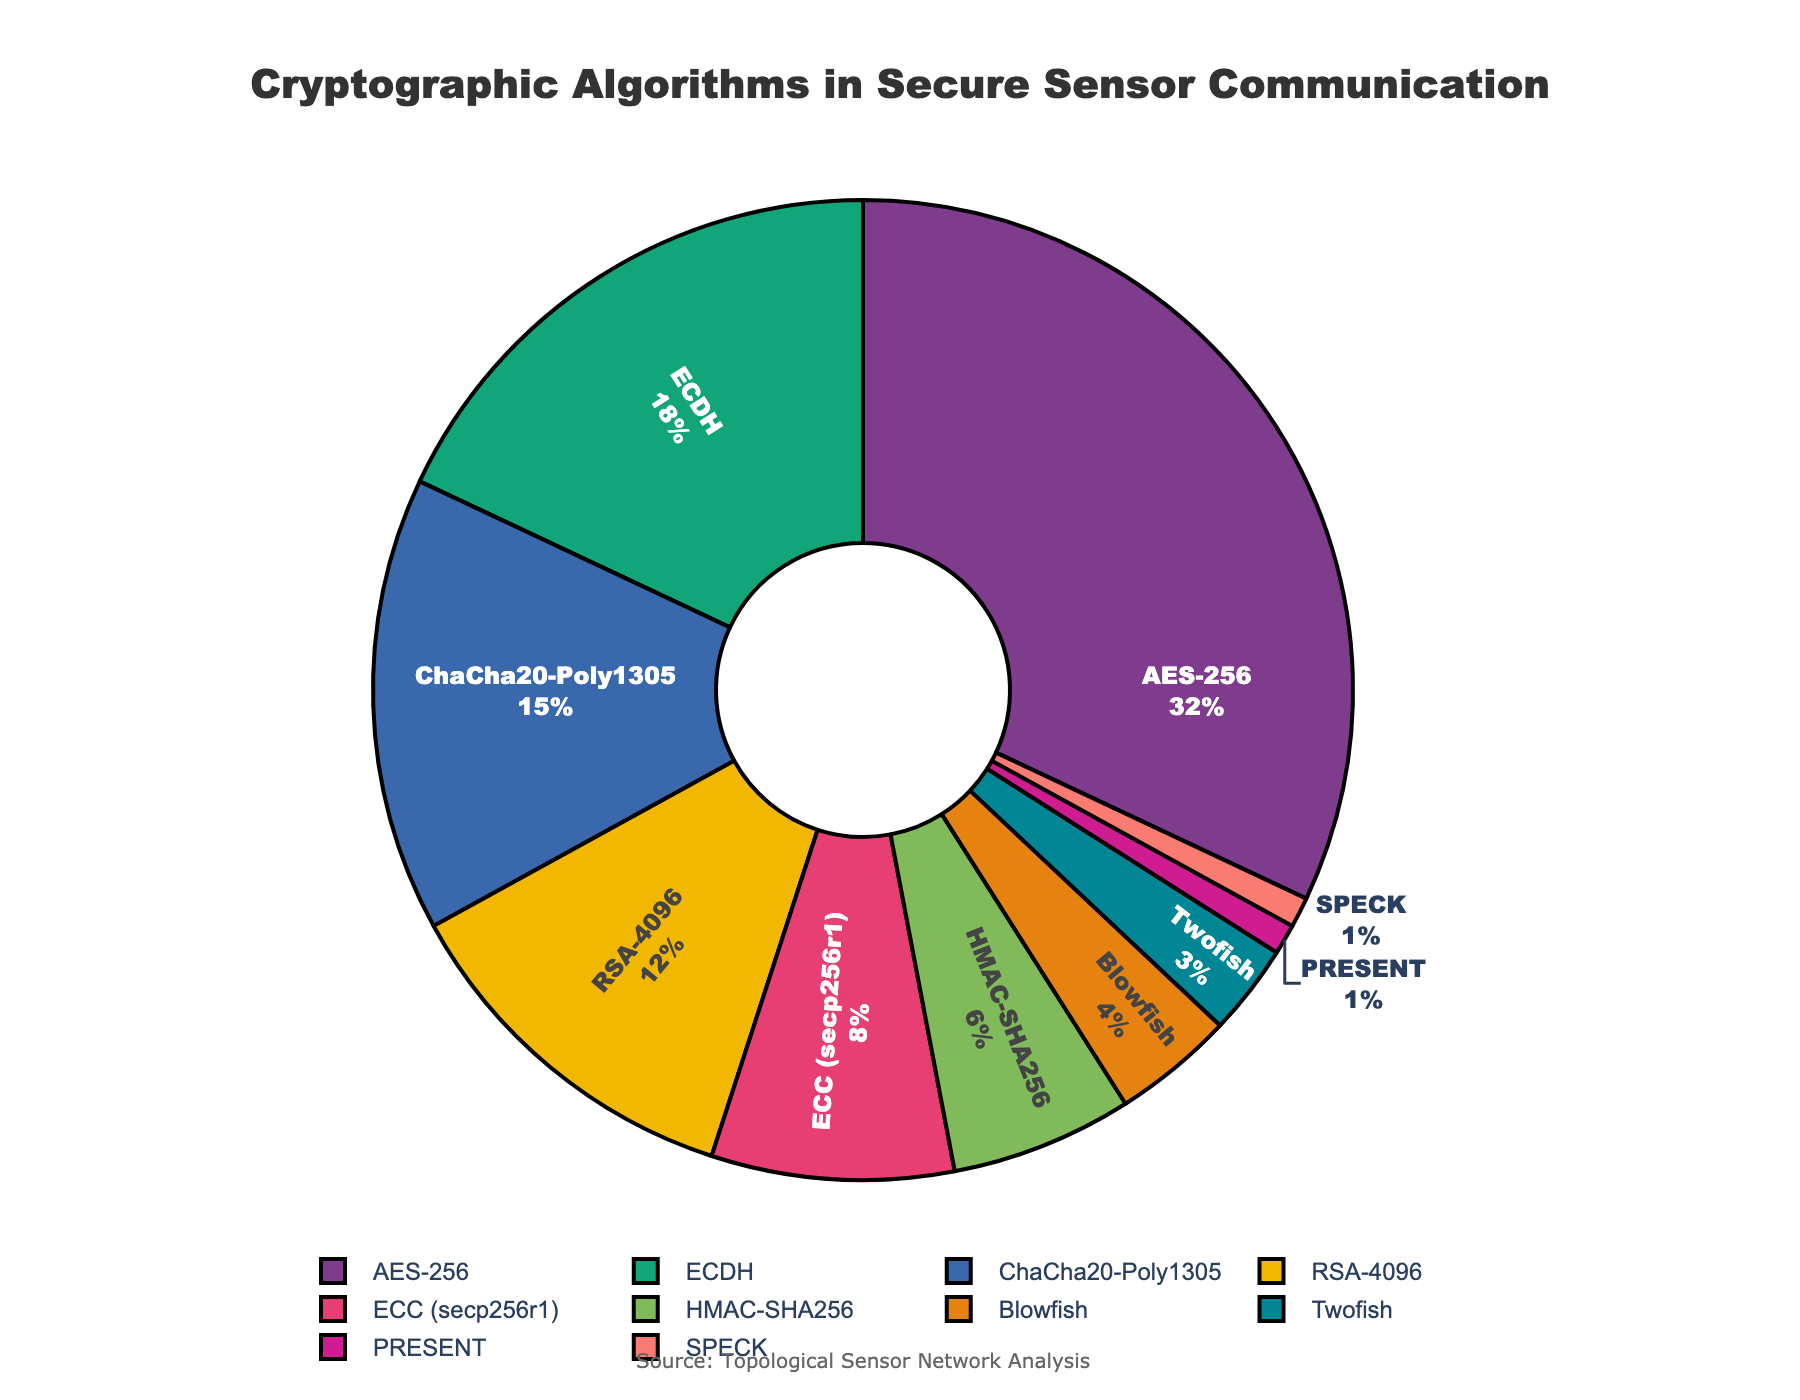Which algorithm occupies the largest percentage in secure sensor communications? The largest segment in the pie chart represents AES-256.
Answer: AES-256 What is the combined percentage of RSA-4096 and ECC (secp256r1)? RSA-4096 is 12% and ECC (secp256r1) is 8%. Adding them together gives 12% + 8% = 20%.
Answer: 20% How does the percentage of HMAC-SHA256 compare to that of SPECK? HMAC-SHA256 occupies 6%, while SPECK occupies 1%. Therefore, HMAC-SHA256 has a larger percentage.
Answer: HMAC-SHA256 has a larger percentage Which algorithms have a percentage lower than 5%? The pie chart shows that Blowfish (4%), Twofish (3%), PRESENT (1%), and SPECK (1%) all have percentages below 5%.
Answer: Blowfish, Twofish, PRESENT, and SPECK Which algorithm contributes exactly one percent to secure sensor communications? There are two algorithms each contributing 1%: PRESENT and SPECK.
Answer: PRESENT and SPECK What is the difference in percentage between AES-256 and ChaCha20-Poly1305? AES-256 occupies 32%, and ChaCha20-Poly1305 occupies 15%. The difference is 32% - 15% = 17%.
Answer: 17% What is the total percentage contributed by ECC (secp256r1) and Blowfish? ECC (secp256r1) is 8% and Blowfish is 4%. Adding them together gives 8% + 4% = 12%.
Answer: 12% By how much does the percentage of ChaCha20-Poly1305 exceed that of Twofish? ChaCha20-Poly1305 is 15% and Twofish is 3%. The difference is 15% - 3% = 12%.
Answer: 12% Out of RSA-4096 and HMAC-SHA256, which algorithm has a higher percentage and by how much? RSA-4096 has a higher percentage (12%) compared to HMAC-SHA256 (6%). The difference is 12% - 6% = 6%.
Answer: RSA-4096 by 6% 